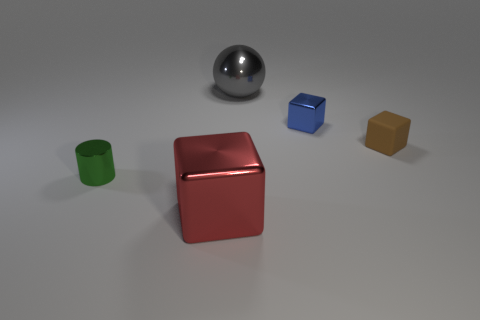Subtract all brown cubes. How many cubes are left? 2 Add 3 metallic balls. How many objects exist? 8 Subtract all cubes. How many objects are left? 2 Subtract 0 gray cylinders. How many objects are left? 5 Subtract all blue spheres. Subtract all cyan cylinders. How many spheres are left? 1 Subtract all large blocks. Subtract all small gray balls. How many objects are left? 4 Add 3 metal objects. How many metal objects are left? 7 Add 5 tiny cyan matte cylinders. How many tiny cyan matte cylinders exist? 5 